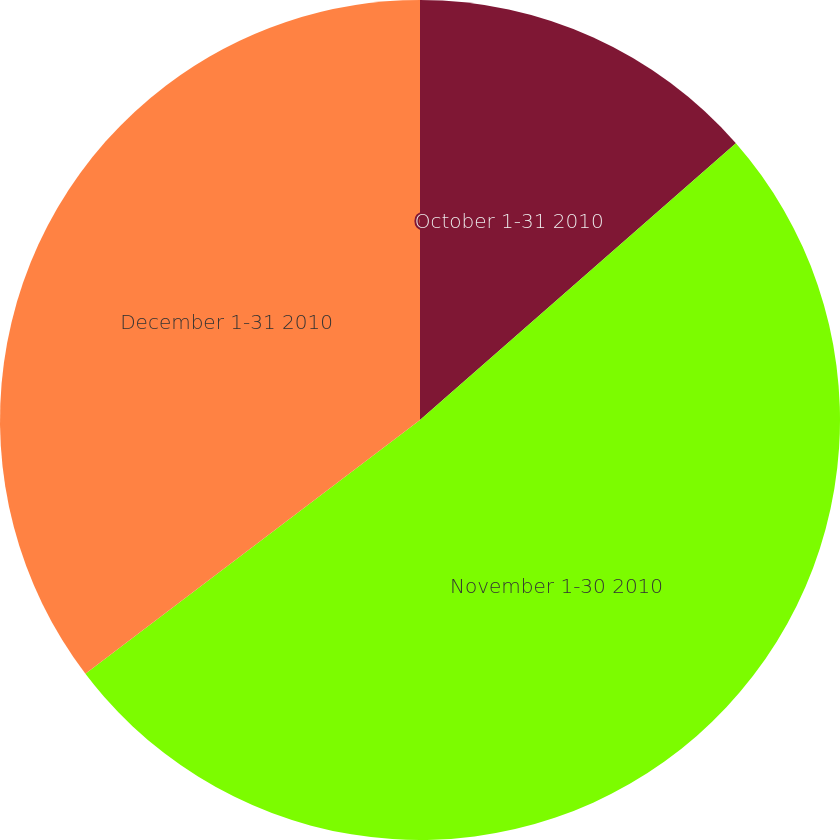<chart> <loc_0><loc_0><loc_500><loc_500><pie_chart><fcel>October 1-31 2010<fcel>November 1-30 2010<fcel>December 1-31 2010<nl><fcel>13.55%<fcel>51.12%<fcel>35.33%<nl></chart> 